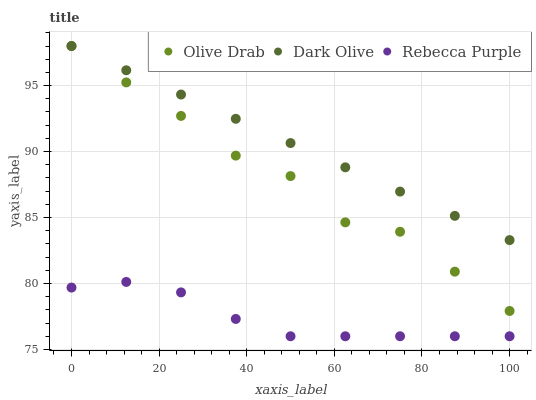Does Rebecca Purple have the minimum area under the curve?
Answer yes or no. Yes. Does Dark Olive have the maximum area under the curve?
Answer yes or no. Yes. Does Olive Drab have the minimum area under the curve?
Answer yes or no. No. Does Olive Drab have the maximum area under the curve?
Answer yes or no. No. Is Dark Olive the smoothest?
Answer yes or no. Yes. Is Olive Drab the roughest?
Answer yes or no. Yes. Is Rebecca Purple the smoothest?
Answer yes or no. No. Is Rebecca Purple the roughest?
Answer yes or no. No. Does Rebecca Purple have the lowest value?
Answer yes or no. Yes. Does Olive Drab have the lowest value?
Answer yes or no. No. Does Olive Drab have the highest value?
Answer yes or no. Yes. Does Rebecca Purple have the highest value?
Answer yes or no. No. Is Rebecca Purple less than Olive Drab?
Answer yes or no. Yes. Is Dark Olive greater than Rebecca Purple?
Answer yes or no. Yes. Does Olive Drab intersect Dark Olive?
Answer yes or no. Yes. Is Olive Drab less than Dark Olive?
Answer yes or no. No. Is Olive Drab greater than Dark Olive?
Answer yes or no. No. Does Rebecca Purple intersect Olive Drab?
Answer yes or no. No. 